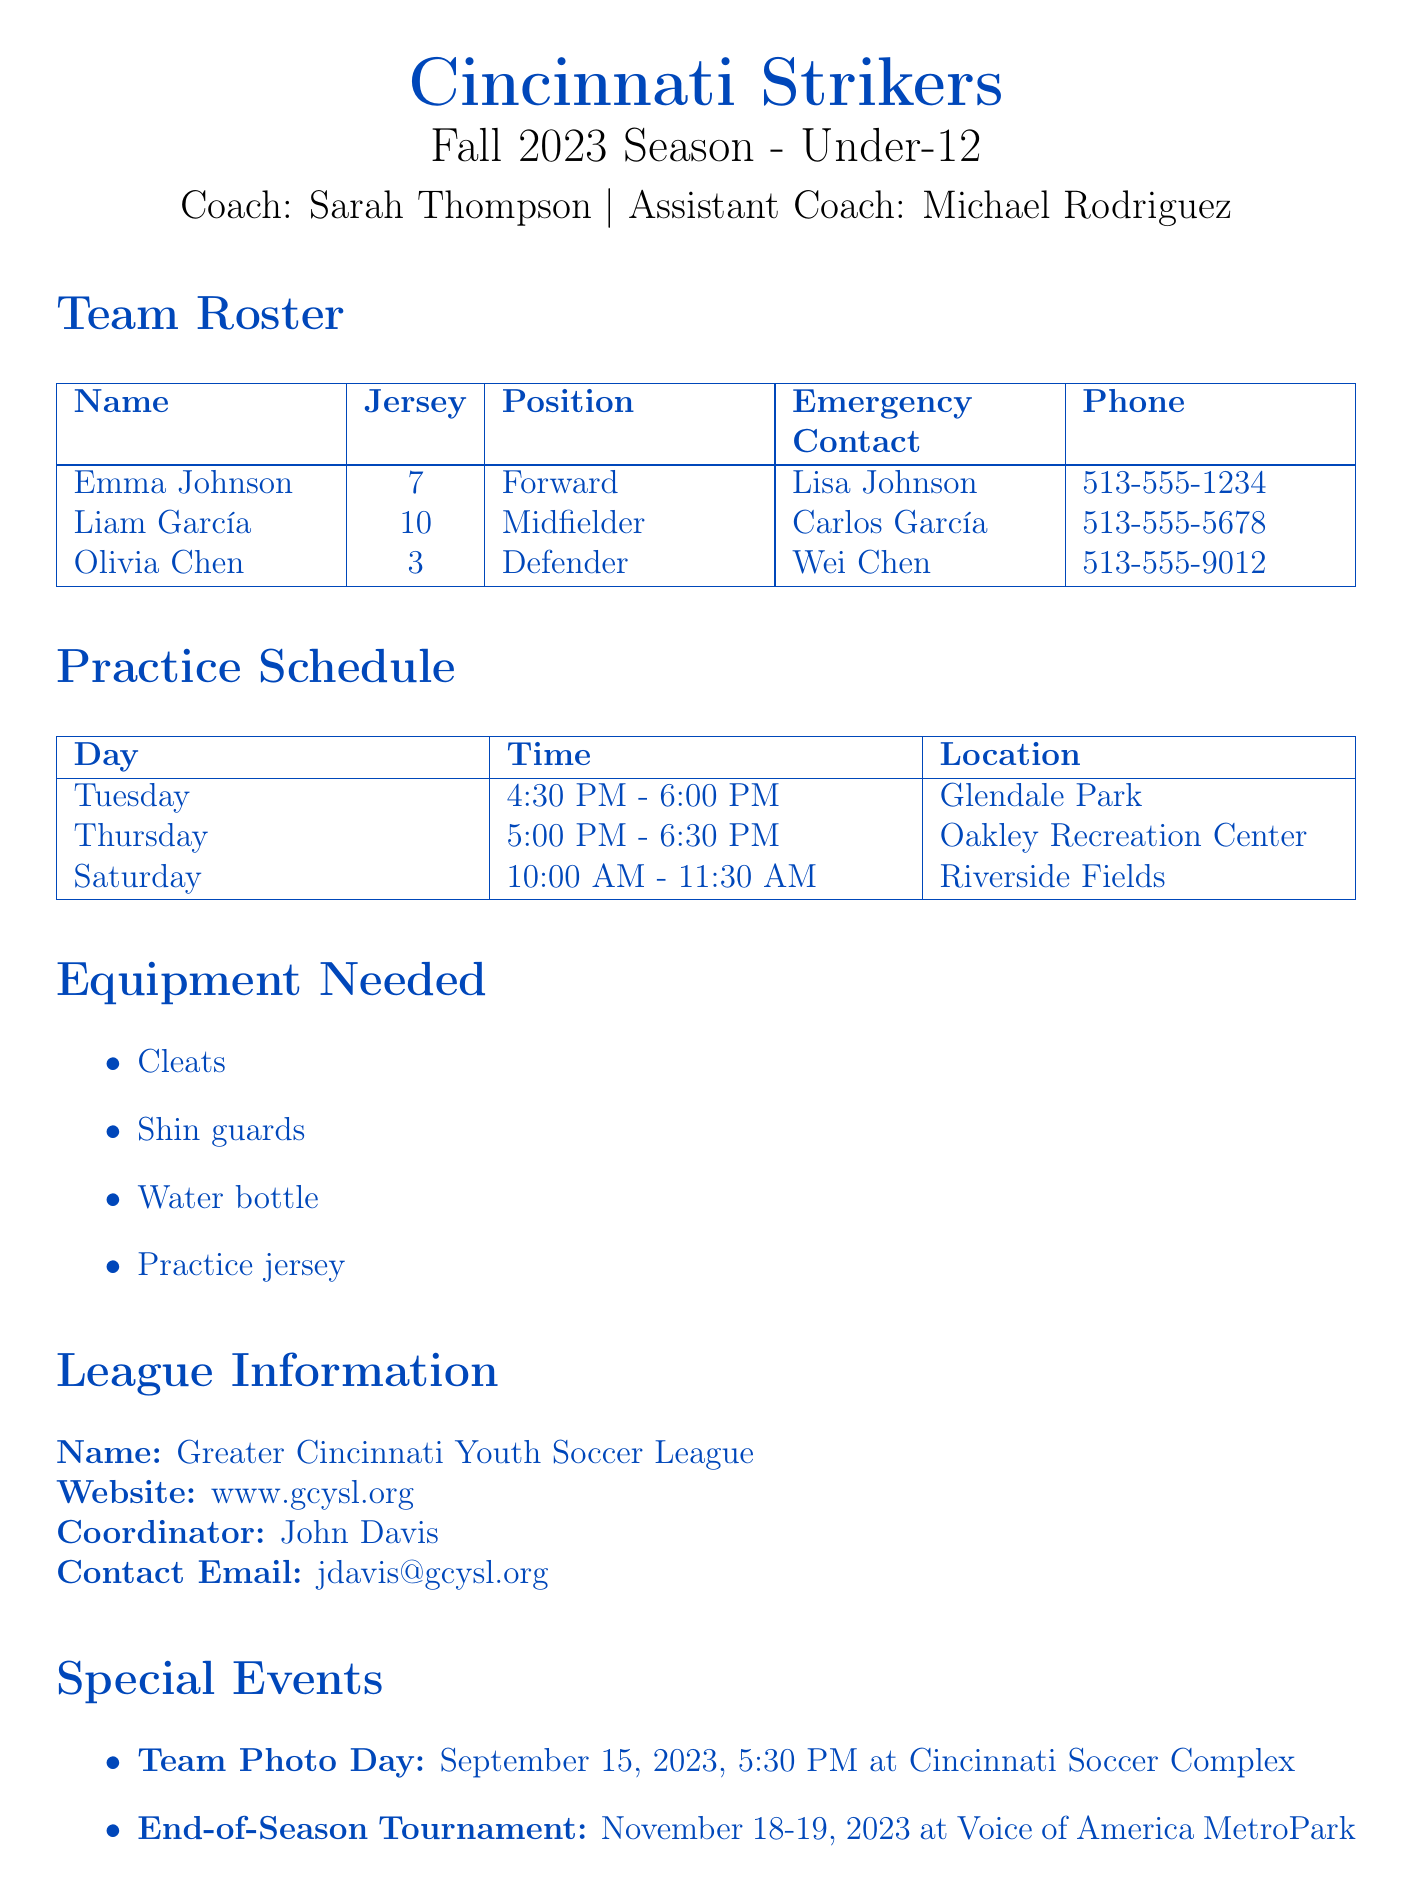What is the team name? The team name is listed at the top of the document.
Answer: Cincinnati Strikers Who is the coach? The document specifies the coach's name in the team information section.
Answer: Sarah Thompson What is the jersey number of Olivia Chen? Olivia Chen's jersey number is provided in the team roster section.
Answer: 3 When is the Team Photo Day? The date for the Team Photo Day is noted under special events.
Answer: September 15, 2023 What location is practice held on Tuesday? The practice schedule indicates the location for each practice day.
Answer: Glendale Park How many players are listed in the roster? The number of players is indicated by the entries in the team roster section.
Answer: 3 What equipment is needed for practice? The equipment section lists items necessary for players during practices.
Answer: Cleats, Shin guards, Water bottle, Practice jersey What time does Saturday practice start? The practice schedule specifies the starting time for practices on each day.
Answer: 10:00 AM What is the contact email for the league coordinator? The league information section includes contact details for further inquiries.
Answer: jdavis@gcysl.org 